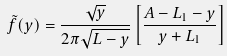<formula> <loc_0><loc_0><loc_500><loc_500>\tilde { f } ( y ) = \frac { \sqrt { y } } { 2 \pi \sqrt { L - y } } \left [ \frac { A - L _ { 1 } - y } { y + L _ { 1 } } \right ]</formula> 